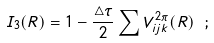<formula> <loc_0><loc_0><loc_500><loc_500>I _ { 3 } ( { R } ) = 1 - \frac { \triangle \tau } { 2 } \sum V ^ { 2 \pi } _ { i j k } ( { R } ) \ ;</formula> 